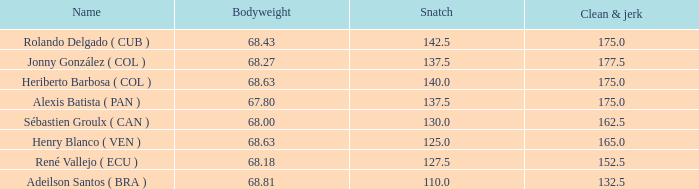5 in clean and jerk when the total kg amounted to 315 and the bodyweight was 6 1.0. 